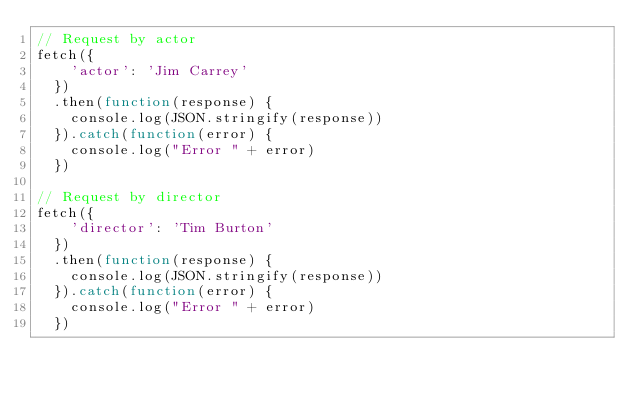Convert code to text. <code><loc_0><loc_0><loc_500><loc_500><_JavaScript_>// Request by actor
fetch({
    'actor': 'Jim Carrey'
  })
  .then(function(response) {
    console.log(JSON.stringify(response))
  }).catch(function(error) {
    console.log("Error " + error)
  })

// Request by director
fetch({
    'director': 'Tim Burton'
  })
  .then(function(response) {
    console.log(JSON.stringify(response))
  }).catch(function(error) {
    console.log("Error " + error)
  })
</code> 